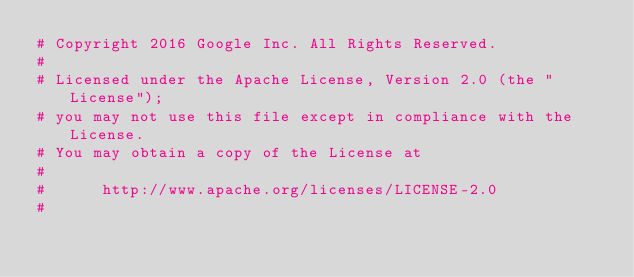Convert code to text. <code><loc_0><loc_0><loc_500><loc_500><_Python_># Copyright 2016 Google Inc. All Rights Reserved.
#
# Licensed under the Apache License, Version 2.0 (the "License");
# you may not use this file except in compliance with the License.
# You may obtain a copy of the License at
#
#      http://www.apache.org/licenses/LICENSE-2.0
#</code> 